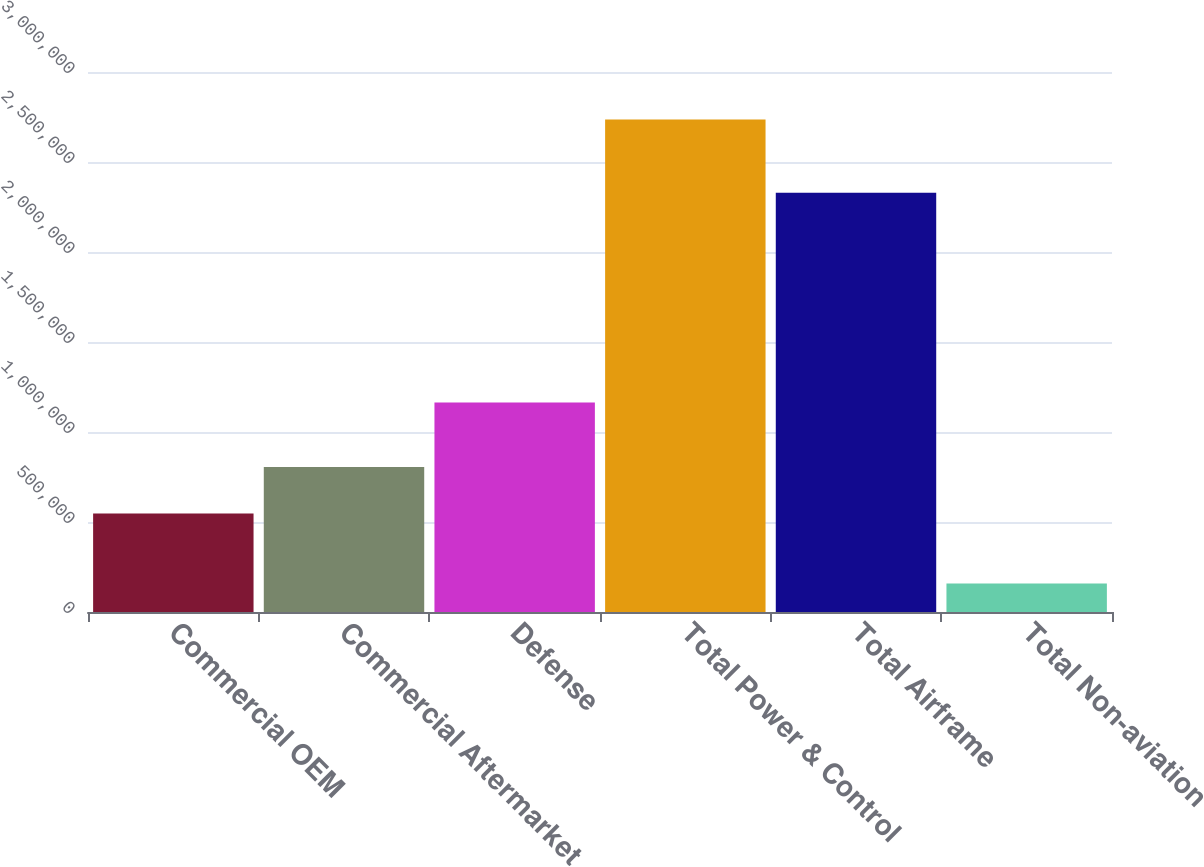<chart> <loc_0><loc_0><loc_500><loc_500><bar_chart><fcel>Commercial OEM<fcel>Commercial Aftermarket<fcel>Defense<fcel>Total Power & Control<fcel>Total Airframe<fcel>Total Non-aviation<nl><fcel>547462<fcel>805197<fcel>1.16454e+06<fcel>2.73557e+06<fcel>2.32941e+06<fcel>158221<nl></chart> 